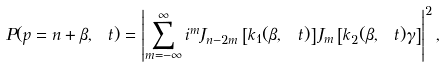Convert formula to latex. <formula><loc_0><loc_0><loc_500><loc_500>P ( p = n + \beta , \ t ) = \left | \sum _ { m = - \infty } ^ { \infty } i ^ { m } J _ { n - 2 m } \left [ k _ { 1 } ( \beta , \ t ) \right ] J _ { m } \left [ k _ { 2 } ( \beta , \ t ) \gamma \right ] \right | ^ { 2 } ,</formula> 